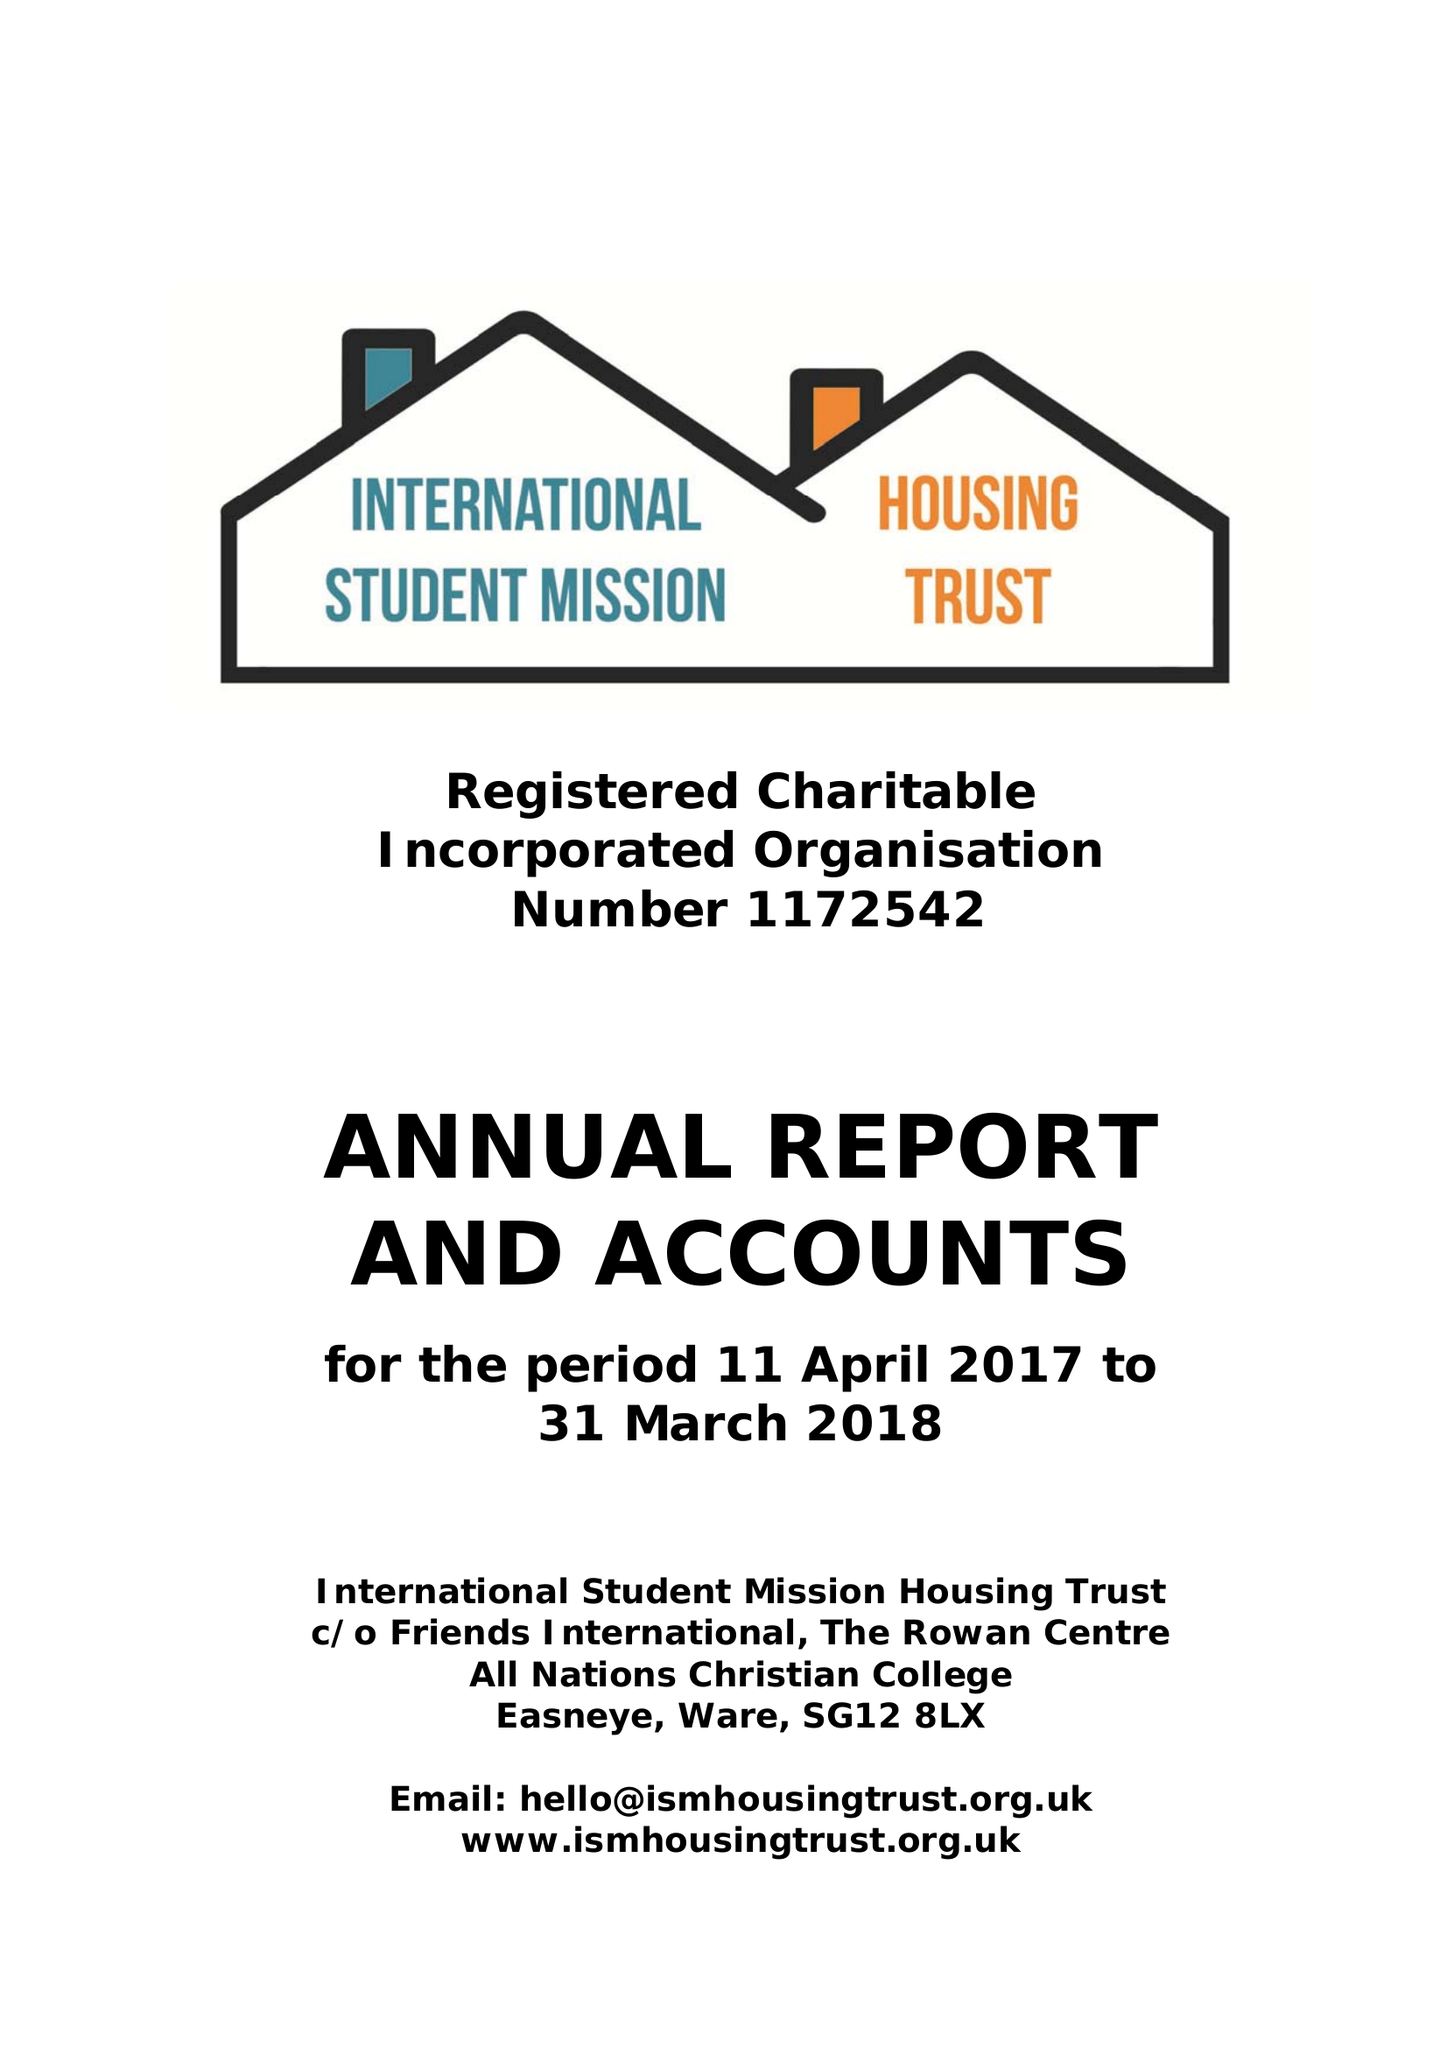What is the value for the report_date?
Answer the question using a single word or phrase. 2018-03-31 